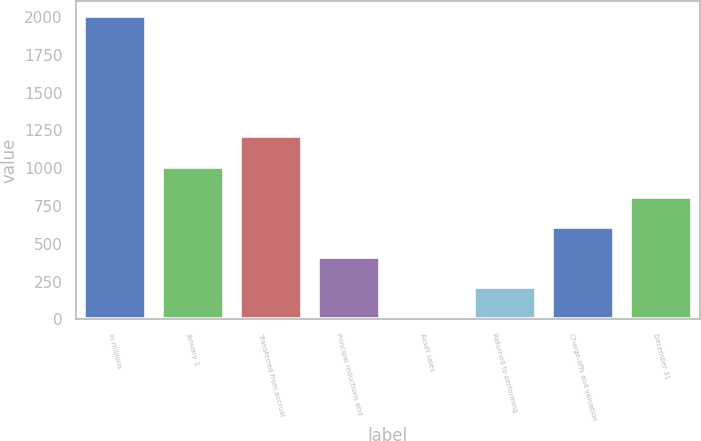Convert chart. <chart><loc_0><loc_0><loc_500><loc_500><bar_chart><fcel>In millions<fcel>January 1<fcel>Transferred from accrual<fcel>Principal reductions and<fcel>Asset sales<fcel>Returned to performing<fcel>Charge-offs and valuation<fcel>December 31<nl><fcel>2006<fcel>1011.5<fcel>1210.4<fcel>414.8<fcel>17<fcel>215.9<fcel>613.7<fcel>812.6<nl></chart> 